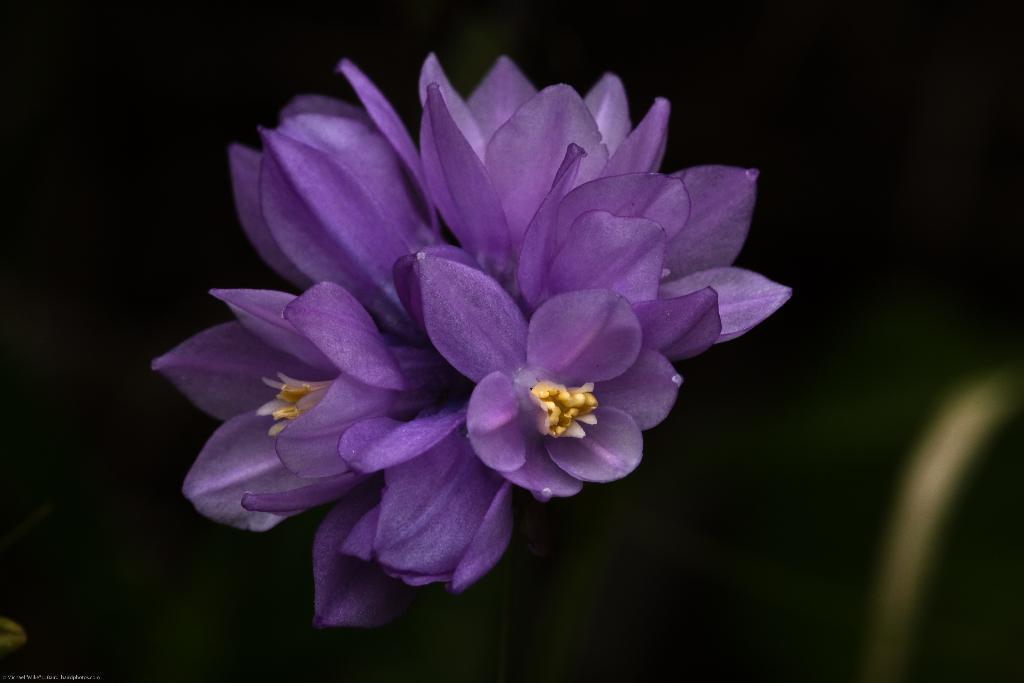How would you summarize this image in a sentence or two? In this image I can see few flowers which are violet, yellow and white in color and I can see the dark background. 